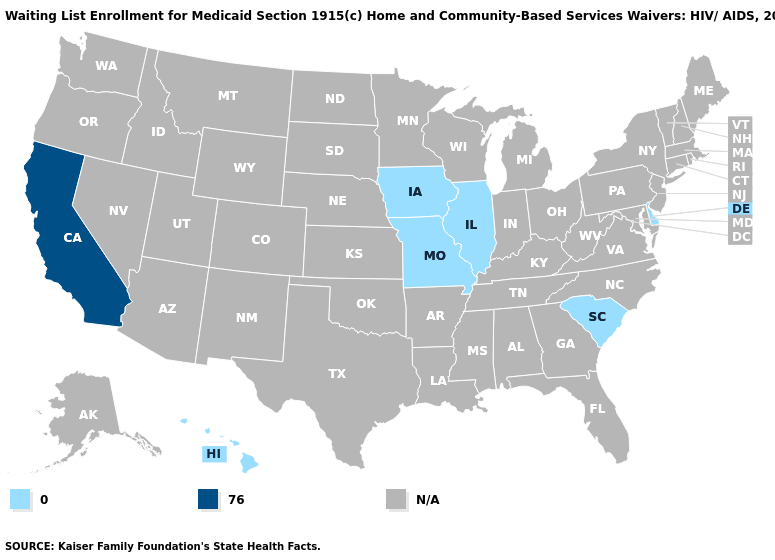Name the states that have a value in the range 76.0?
Give a very brief answer. California. Name the states that have a value in the range 0.0?
Quick response, please. Delaware, Hawaii, Illinois, Iowa, Missouri, South Carolina. What is the value of Vermont?
Be succinct. N/A. Does California have the highest value in the West?
Be succinct. Yes. Name the states that have a value in the range N/A?
Be succinct. Alabama, Alaska, Arizona, Arkansas, Colorado, Connecticut, Florida, Georgia, Idaho, Indiana, Kansas, Kentucky, Louisiana, Maine, Maryland, Massachusetts, Michigan, Minnesota, Mississippi, Montana, Nebraska, Nevada, New Hampshire, New Jersey, New Mexico, New York, North Carolina, North Dakota, Ohio, Oklahoma, Oregon, Pennsylvania, Rhode Island, South Dakota, Tennessee, Texas, Utah, Vermont, Virginia, Washington, West Virginia, Wisconsin, Wyoming. Which states hav the highest value in the West?
Give a very brief answer. California. Name the states that have a value in the range 76.0?
Give a very brief answer. California. Which states have the lowest value in the USA?
Give a very brief answer. Delaware, Hawaii, Illinois, Iowa, Missouri, South Carolina. Does Delaware have the highest value in the USA?
Give a very brief answer. No. Which states have the lowest value in the MidWest?
Answer briefly. Illinois, Iowa, Missouri. What is the highest value in the South ?
Be succinct. 0.0. 